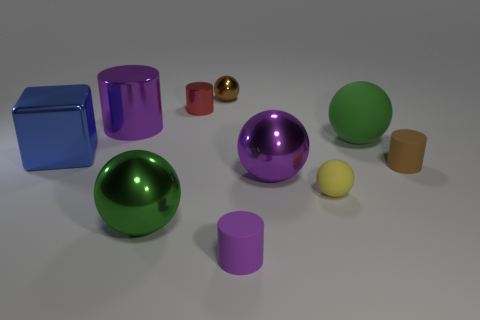Subtract all green balls. How many balls are left? 3 Subtract all yellow matte spheres. How many spheres are left? 4 Subtract 2 balls. How many balls are left? 3 Subtract all blue cylinders. Subtract all yellow cubes. How many cylinders are left? 4 Subtract all blocks. How many objects are left? 9 Add 1 tiny purple objects. How many tiny purple objects are left? 2 Add 10 big purple matte objects. How many big purple matte objects exist? 10 Subtract 1 green spheres. How many objects are left? 9 Subtract all cylinders. Subtract all brown objects. How many objects are left? 4 